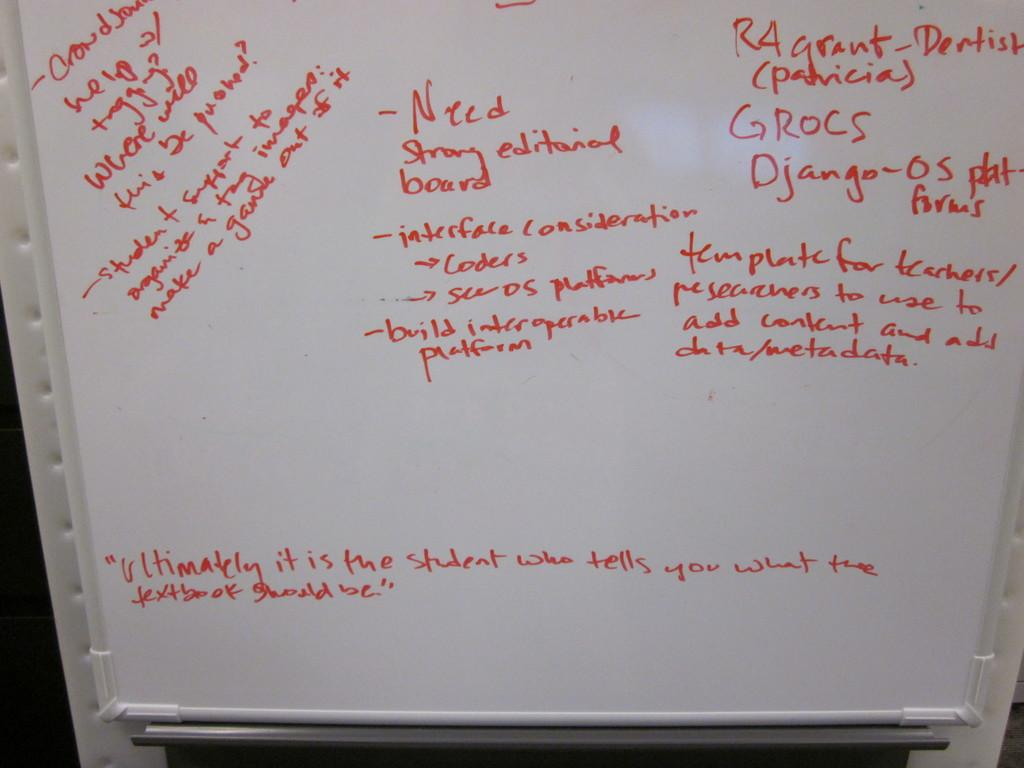<image>
Summarize the visual content of the image. A white board has s statement in the center that says needs a strong editorial board. 